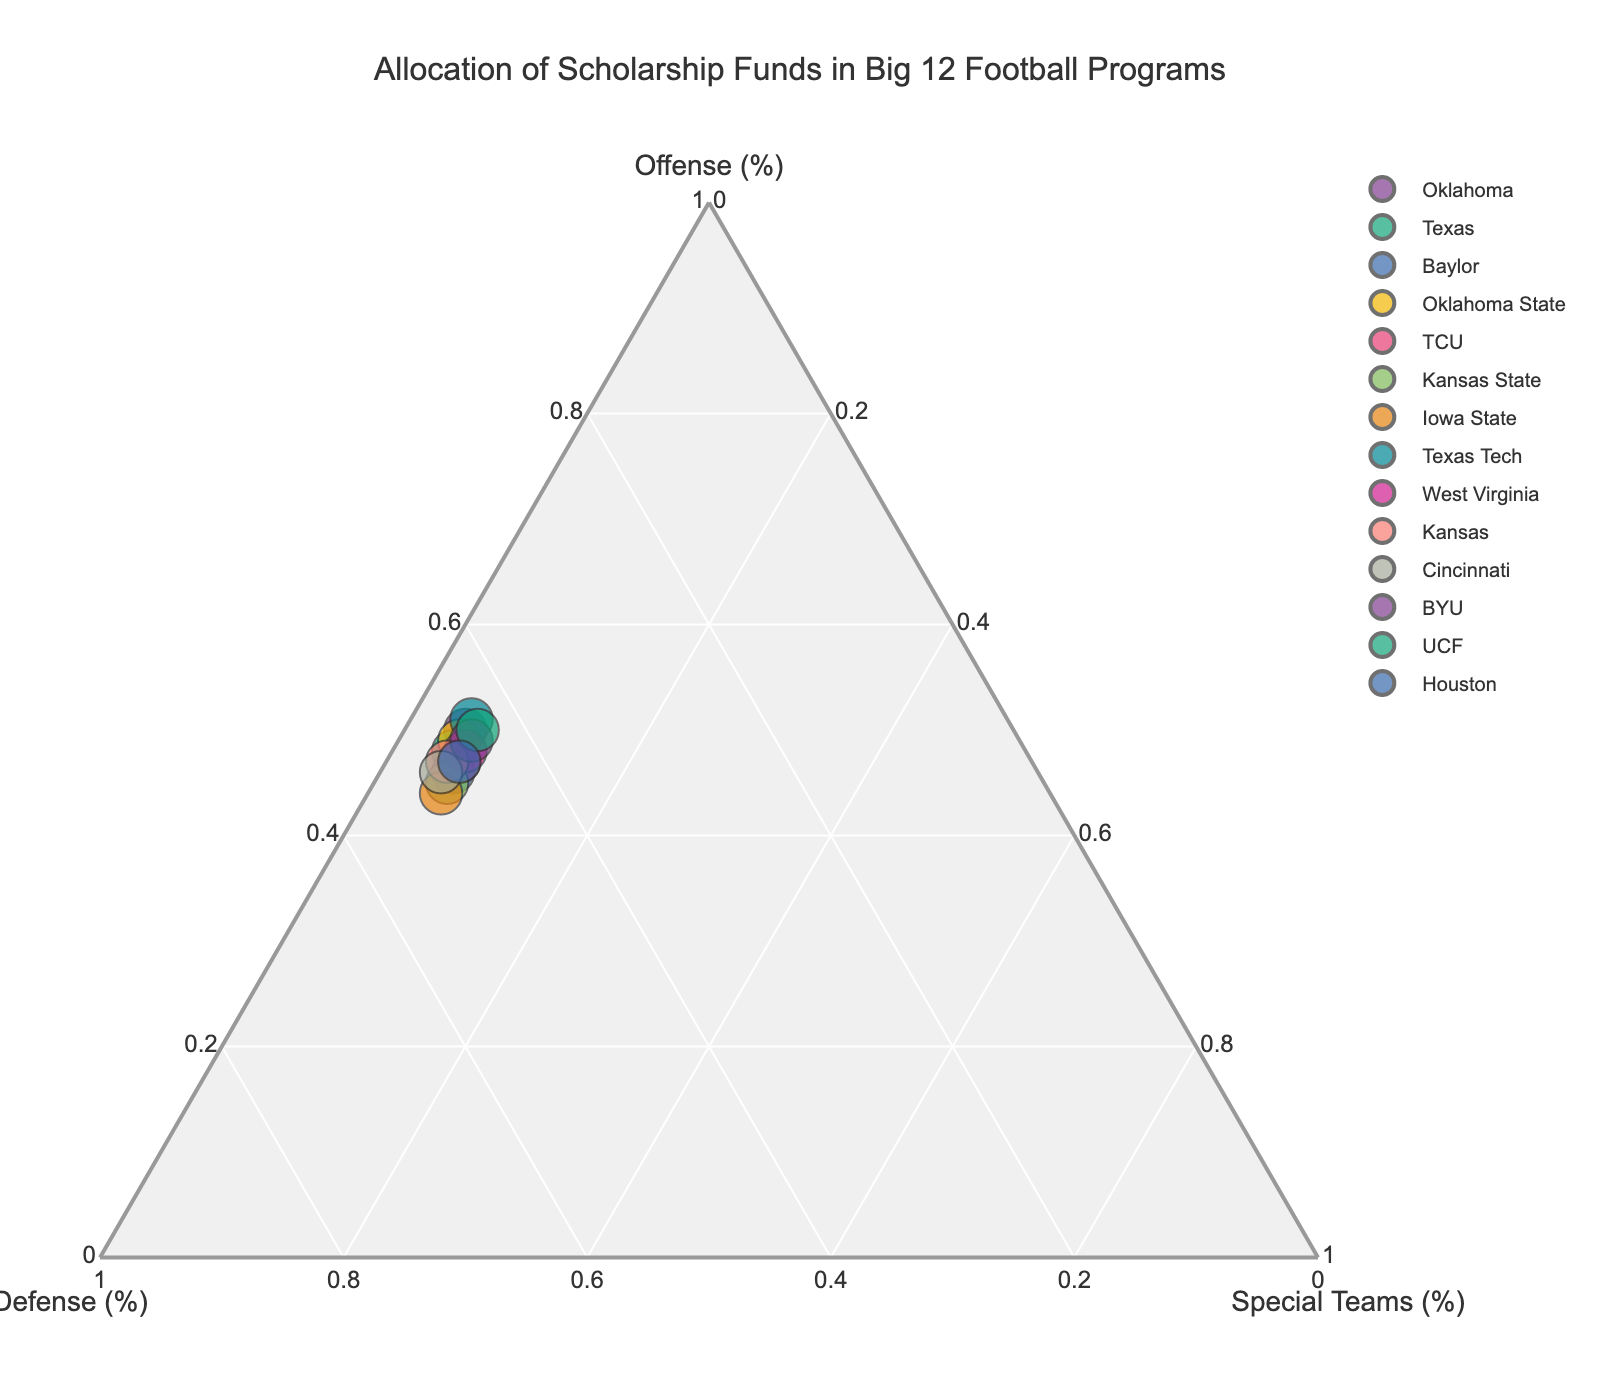What is the title of the ternary plot? The title is typically found at the top of the figure, often the largest text in the plot layout. In this case, it is indicated as "Allocation of Scholarship Funds in Big 12 Football Programs."
Answer: Allocation of Scholarship Funds in Big 12 Football Programs How are the percentages for Offense plotted? The Offense percentages are plotted along the left axis of the ternary plot, indicated by the label "Offense (%)" along that axis.
Answer: Left axis Which team has the highest percentage allocation for Defense? To identify this, look for the team placed closest to the Defense axis (labeled "Defense (%)") near the 50% mark. According to the data provided, Iowa State allocates 50% to Defense.
Answer: Iowa State What is the general trend between Offense and Special Teams for most teams? By observing the placement of the teams, it appears that as the allocation to Offense increases, the allocation to Special Teams slightly decreases. This is visible since points near higher Offense percentages usually show lower Special Teams percentages.
Answer: Inverse relationship Which teams allocate the same percentage to Defense and Offense? Look for teams located along the line between the Offense and Defense axes where both percentages would be similar. Texas and TCU both allocate 47% to Defense and Offense.
Answer: Texas, TCU Which team allocates the largest percentage to Offense? The team positioned closest to the pinnacle of the Offense axis (labeled as "Offense (%)") should represent the one with the largest allocation. Texas Tech, allocating 51% to Offense, is the highest.
Answer: Texas Tech How many teams allocate more than 45% to Special Teams? Observing that no teams allocate more than about 6% to Special Teams based on the data, you can determine that no team allocates more than 45% to Special Teams.
Answer: 0 Which team has the smallest allocation for Special Teams? Check the Special Teams axis (labeled "Special Teams (%)") and find the position closest to the base of the axis. Oklahoma allocates the least percentage to Special Teams, at 5%.
Answer: Oklahoma What is the average percentage allocated to Defense across all teams? Calculate the average by summing all Defense percentages (45+47+48+46+47+49+50+44+46+48+49+45+44+47) and dividing by the number of teams (14). The sum is 699, and the average is 699/14.
Answer: 49.9% Which team has the most balanced allocation among Offense, Defense, and Special Teams? "Balanced" implies that the percentages are relatively even across the categories. TCU allocates 47% to Offense, 47% to Defense, and 6% to Special Teams, making it the most balanced.
Answer: TCU 